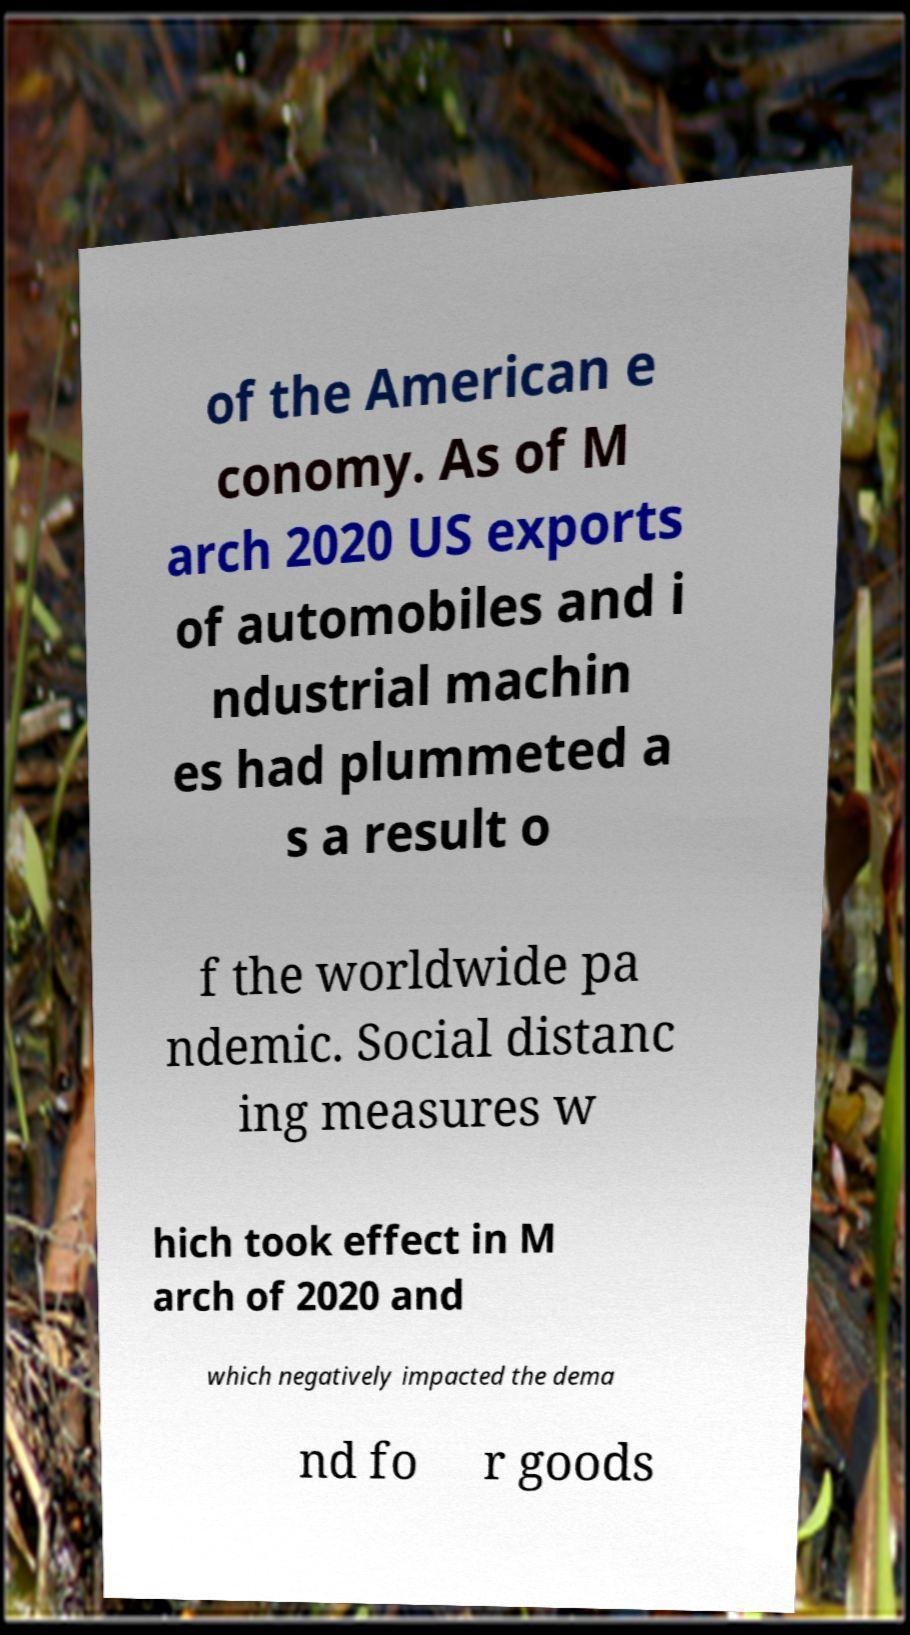What messages or text are displayed in this image? I need them in a readable, typed format. of the American e conomy. As of M arch 2020 US exports of automobiles and i ndustrial machin es had plummeted a s a result o f the worldwide pa ndemic. Social distanc ing measures w hich took effect in M arch of 2020 and which negatively impacted the dema nd fo r goods 